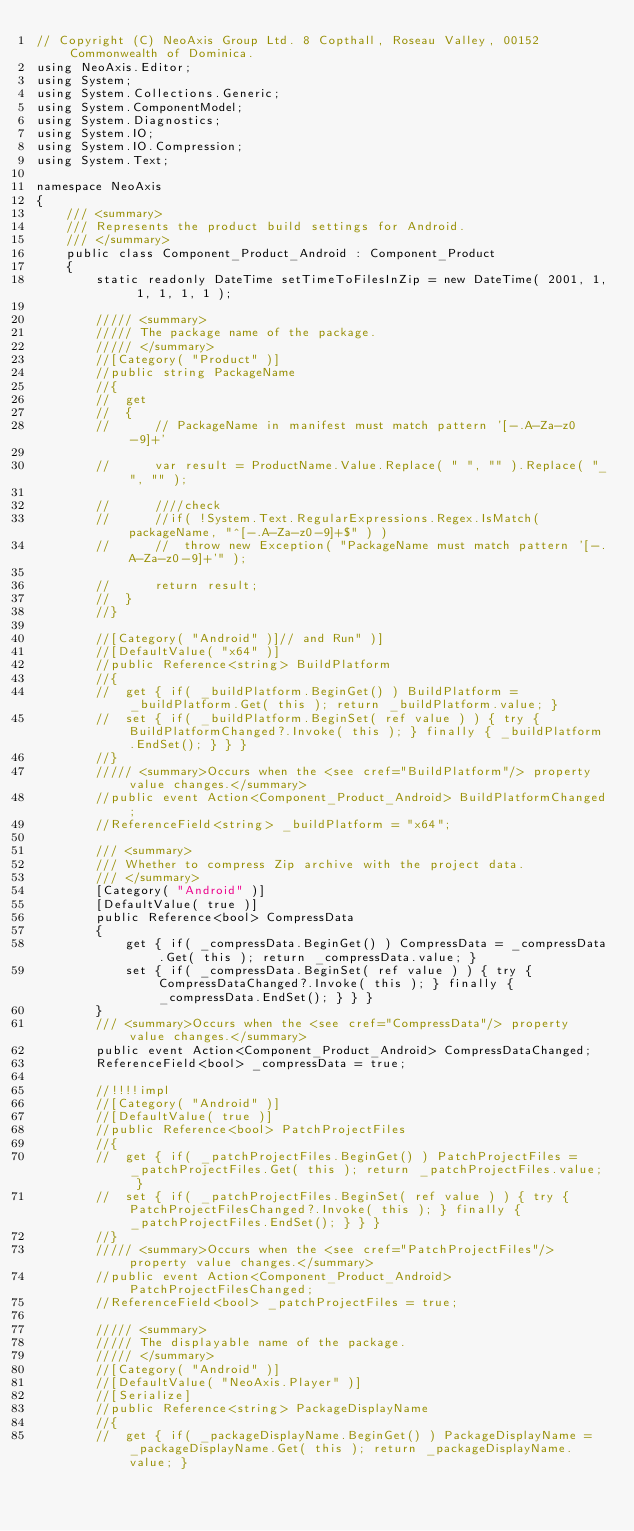<code> <loc_0><loc_0><loc_500><loc_500><_C#_>// Copyright (C) NeoAxis Group Ltd. 8 Copthall, Roseau Valley, 00152 Commonwealth of Dominica.
using NeoAxis.Editor;
using System;
using System.Collections.Generic;
using System.ComponentModel;
using System.Diagnostics;
using System.IO;
using System.IO.Compression;
using System.Text;

namespace NeoAxis
{
	/// <summary>
	/// Represents the product build settings for Android.
	/// </summary>
	public class Component_Product_Android : Component_Product
	{
		static readonly DateTime setTimeToFilesInZip = new DateTime( 2001, 1, 1, 1, 1, 1 );

		///// <summary>
		///// The package name of the package.
		///// </summary>
		//[Category( "Product" )]
		//public string PackageName
		//{
		//	get
		//	{
		//		// PackageName in manifest must match pattern '[-.A-Za-z0-9]+'

		//		var result = ProductName.Value.Replace( " ", "" ).Replace( "_", "" );

		//		////check
		//		//if( !System.Text.RegularExpressions.Regex.IsMatch( packageName, "^[-.A-Za-z0-9]+$" ) )
		//		//	throw new Exception( "PackageName must match pattern '[-.A-Za-z0-9]+'" );

		//		return result;
		//	}
		//}

		//[Category( "Android" )]// and Run" )]
		//[DefaultValue( "x64" )]
		//public Reference<string> BuildPlatform
		//{
		//	get { if( _buildPlatform.BeginGet() ) BuildPlatform = _buildPlatform.Get( this ); return _buildPlatform.value; }
		//	set { if( _buildPlatform.BeginSet( ref value ) ) { try { BuildPlatformChanged?.Invoke( this ); } finally { _buildPlatform.EndSet(); } } }
		//}
		///// <summary>Occurs when the <see cref="BuildPlatform"/> property value changes.</summary>
		//public event Action<Component_Product_Android> BuildPlatformChanged;
		//ReferenceField<string> _buildPlatform = "x64";

		/// <summary>
		/// Whether to compress Zip archive with the project data.
		/// </summary>
		[Category( "Android" )]
		[DefaultValue( true )]
		public Reference<bool> CompressData
		{
			get { if( _compressData.BeginGet() ) CompressData = _compressData.Get( this ); return _compressData.value; }
			set { if( _compressData.BeginSet( ref value ) ) { try { CompressDataChanged?.Invoke( this ); } finally { _compressData.EndSet(); } } }
		}
		/// <summary>Occurs when the <see cref="CompressData"/> property value changes.</summary>
		public event Action<Component_Product_Android> CompressDataChanged;
		ReferenceField<bool> _compressData = true;

		//!!!!impl
		//[Category( "Android" )]
		//[DefaultValue( true )]
		//public Reference<bool> PatchProjectFiles
		//{
		//	get { if( _patchProjectFiles.BeginGet() ) PatchProjectFiles = _patchProjectFiles.Get( this ); return _patchProjectFiles.value; }
		//	set { if( _patchProjectFiles.BeginSet( ref value ) ) { try { PatchProjectFilesChanged?.Invoke( this ); } finally { _patchProjectFiles.EndSet(); } } }
		//}
		///// <summary>Occurs when the <see cref="PatchProjectFiles"/> property value changes.</summary>
		//public event Action<Component_Product_Android> PatchProjectFilesChanged;
		//ReferenceField<bool> _patchProjectFiles = true;

		///// <summary>
		///// The displayable name of the package.
		///// </summary>
		//[Category( "Android" )]
		//[DefaultValue( "NeoAxis.Player" )]
		//[Serialize]
		//public Reference<string> PackageDisplayName
		//{
		//	get { if( _packageDisplayName.BeginGet() ) PackageDisplayName = _packageDisplayName.Get( this ); return _packageDisplayName.value; }</code> 